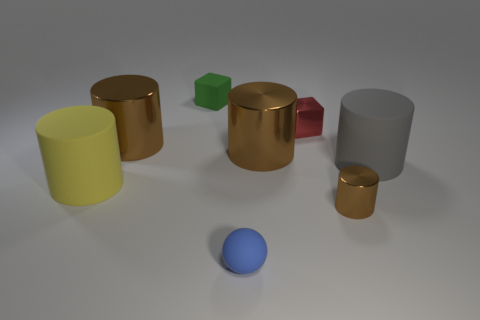Subtract all gray spheres. How many brown cylinders are left? 3 Subtract all gray cylinders. How many cylinders are left? 4 Subtract all yellow matte cylinders. How many cylinders are left? 4 Subtract 2 cylinders. How many cylinders are left? 3 Subtract all red cylinders. Subtract all gray blocks. How many cylinders are left? 5 Add 1 blue balls. How many objects exist? 9 Subtract all cubes. How many objects are left? 6 Subtract 0 gray cubes. How many objects are left? 8 Subtract all large gray rubber cylinders. Subtract all brown things. How many objects are left? 4 Add 4 tiny red cubes. How many tiny red cubes are left? 5 